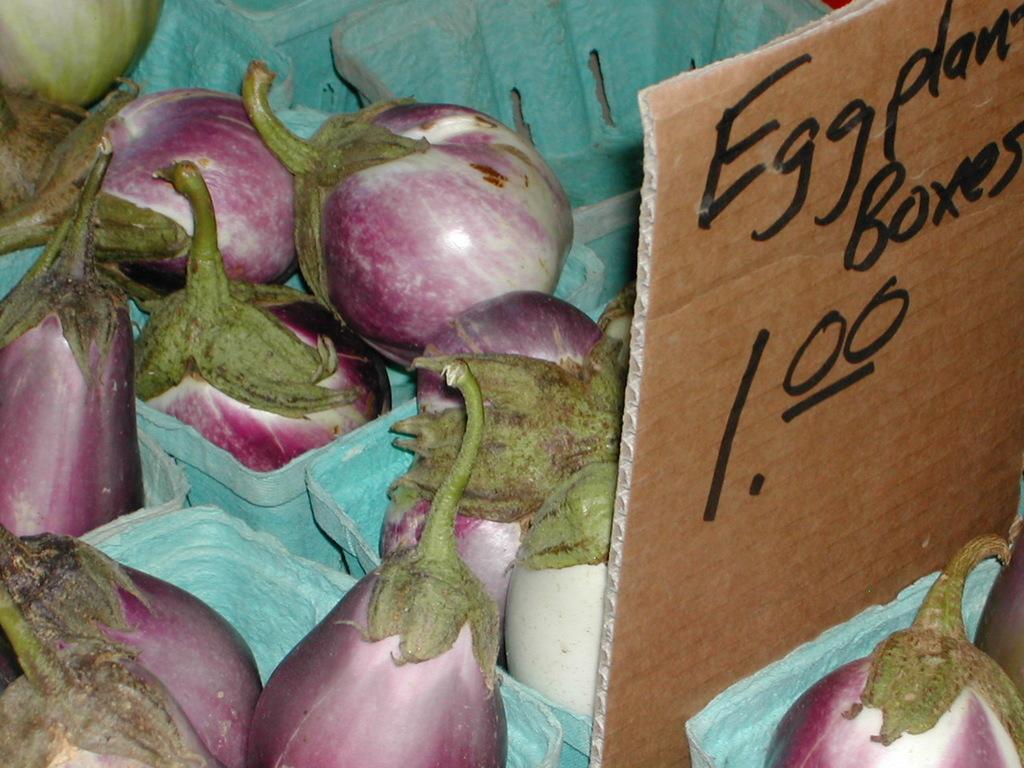In one or two sentences, can you explain what this image depicts? In this picture I can see there are few eggplant, they are placed in a box, there is a board here at right side and there is something written on it. 